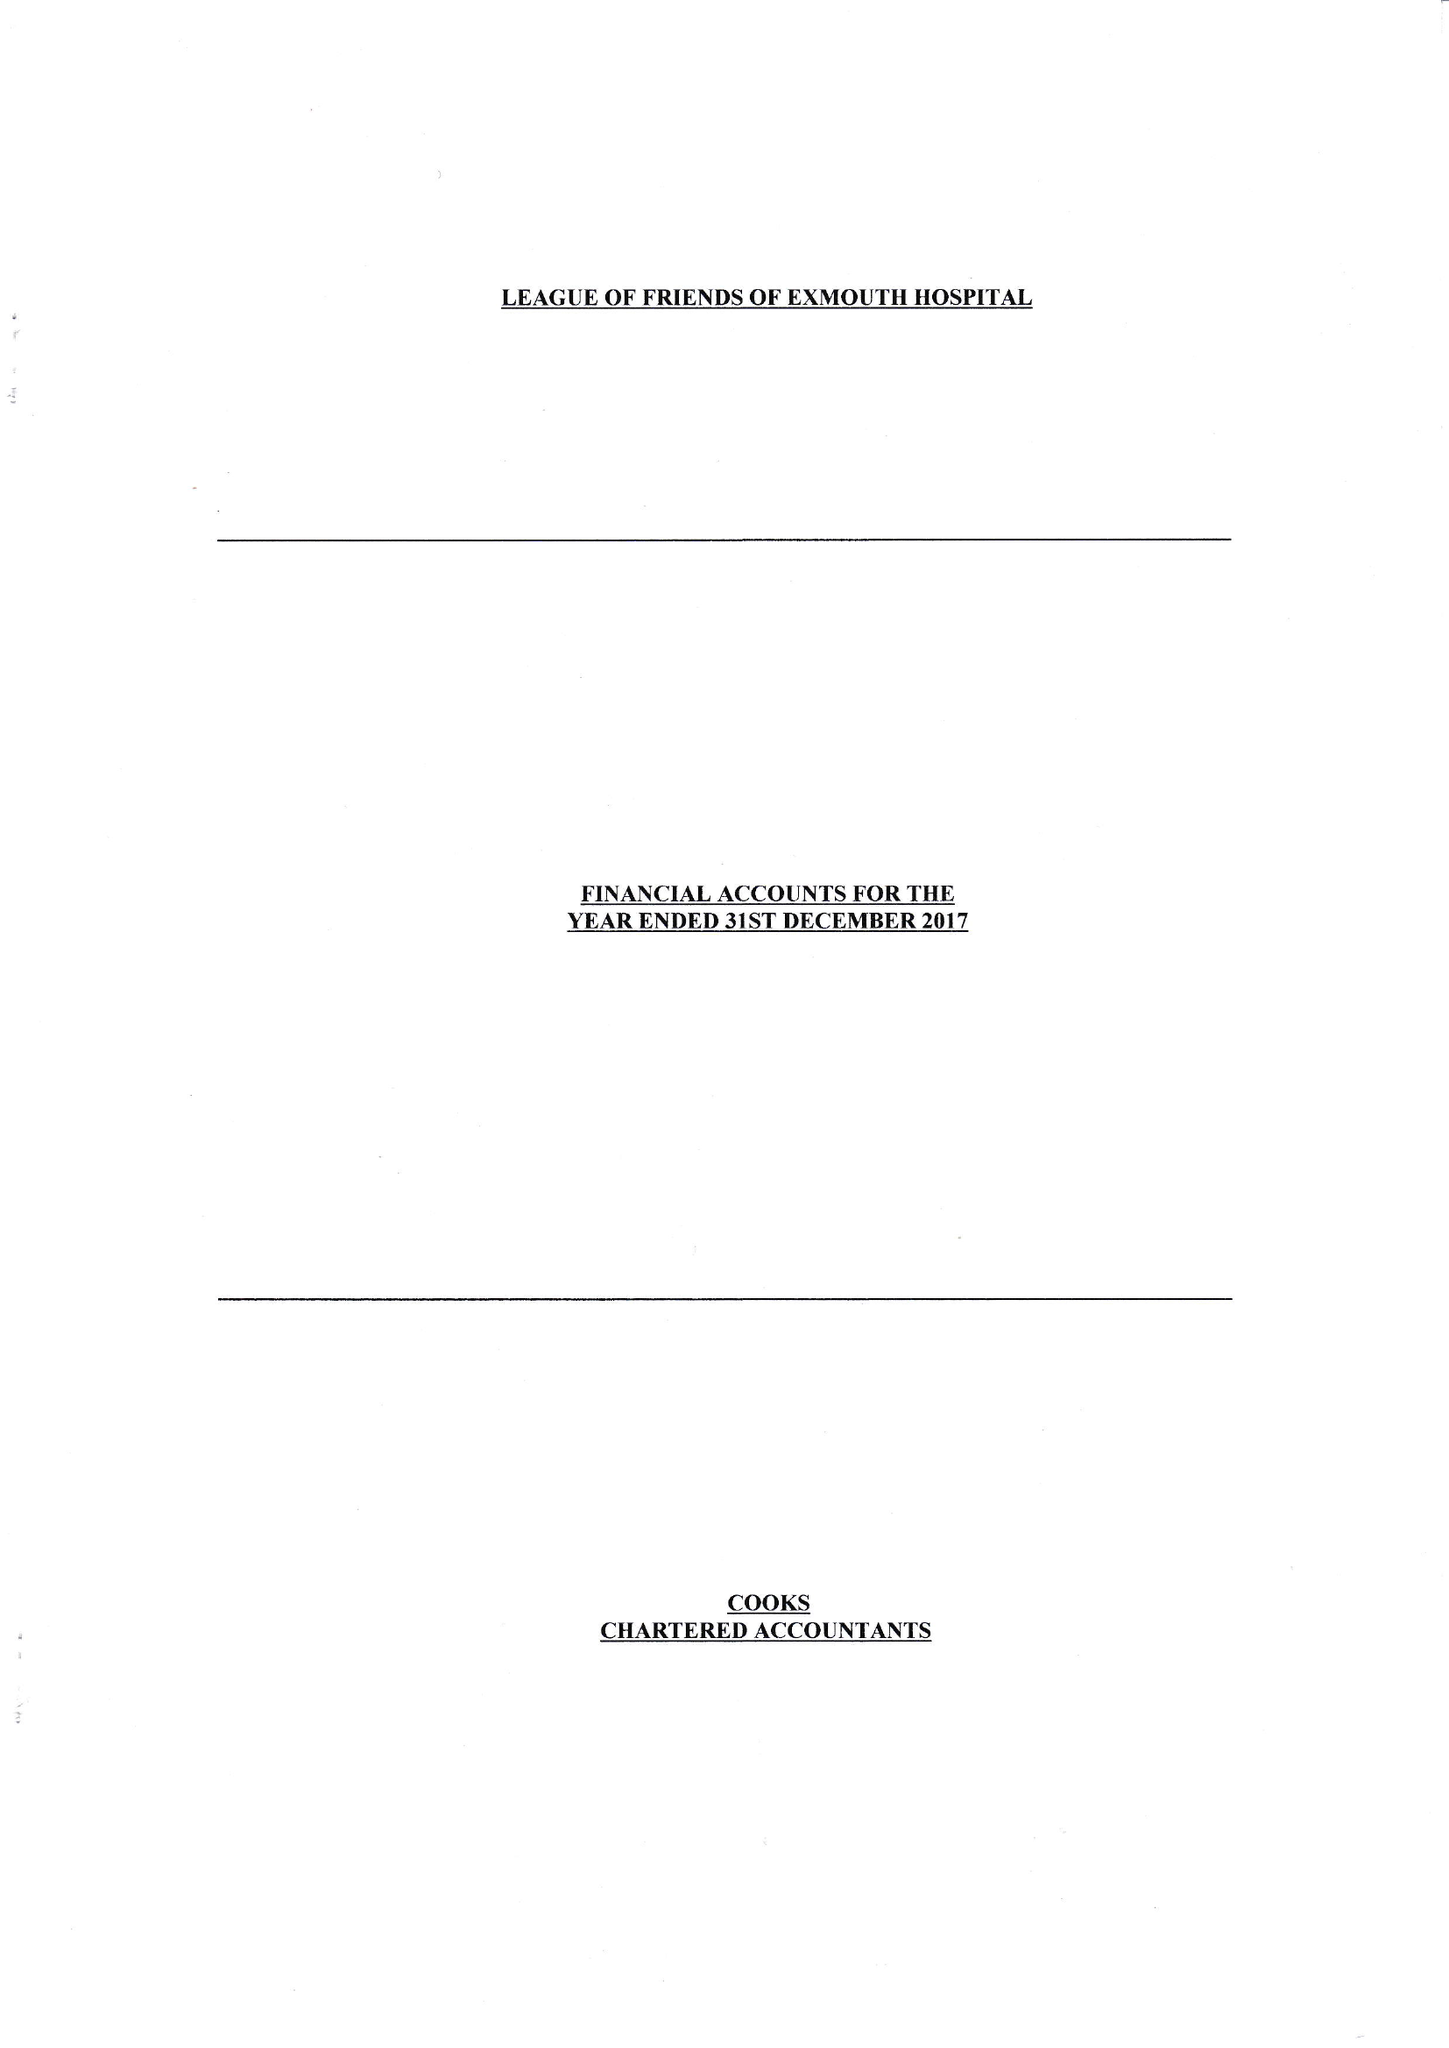What is the value for the spending_annually_in_british_pounds?
Answer the question using a single word or phrase. 43654.00 